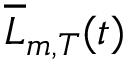Convert formula to latex. <formula><loc_0><loc_0><loc_500><loc_500>{ \overline { L } _ { m , T } } ( t )</formula> 